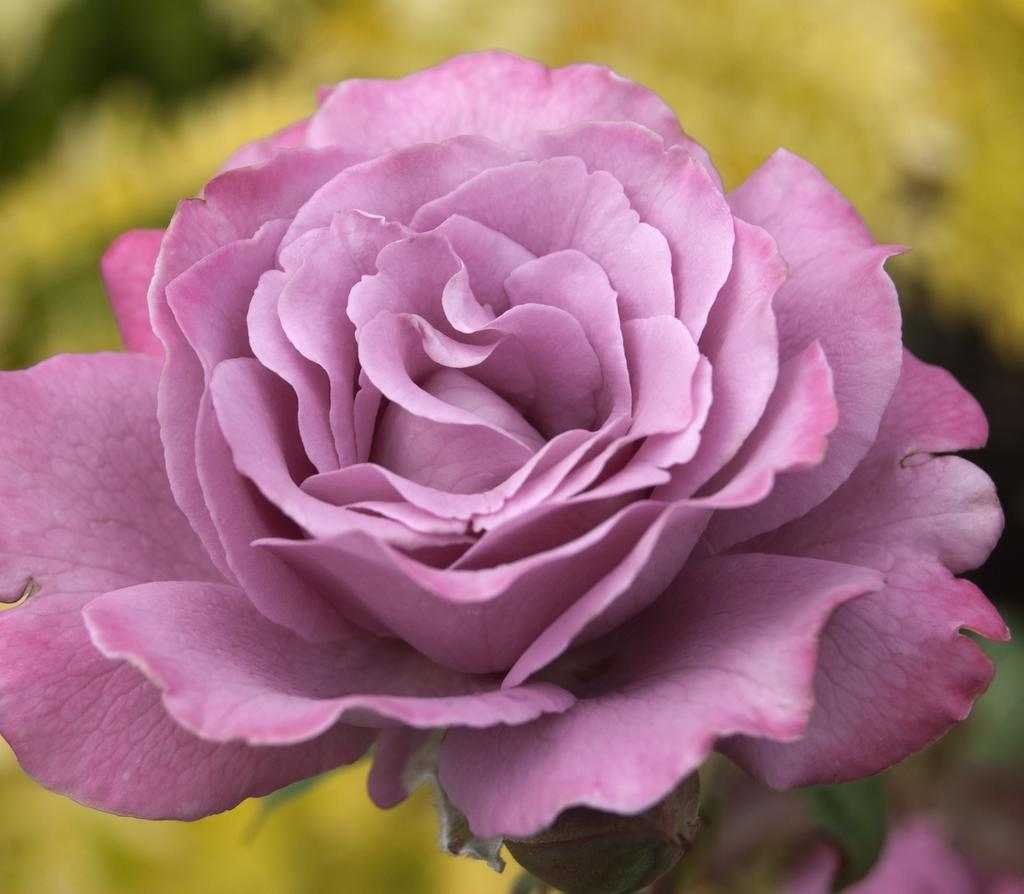What type of flower is in the picture? There is a rose flower in the picture. What color is the rose flower? The rose flower is pink in color. Can you describe the background of the image? The background of the image is yellow and blurred. What type of cast can be seen on the throat of the rose flower in the image? There is no cast or throat present on the rose flower in the image, as it is a flower and not a living being. 